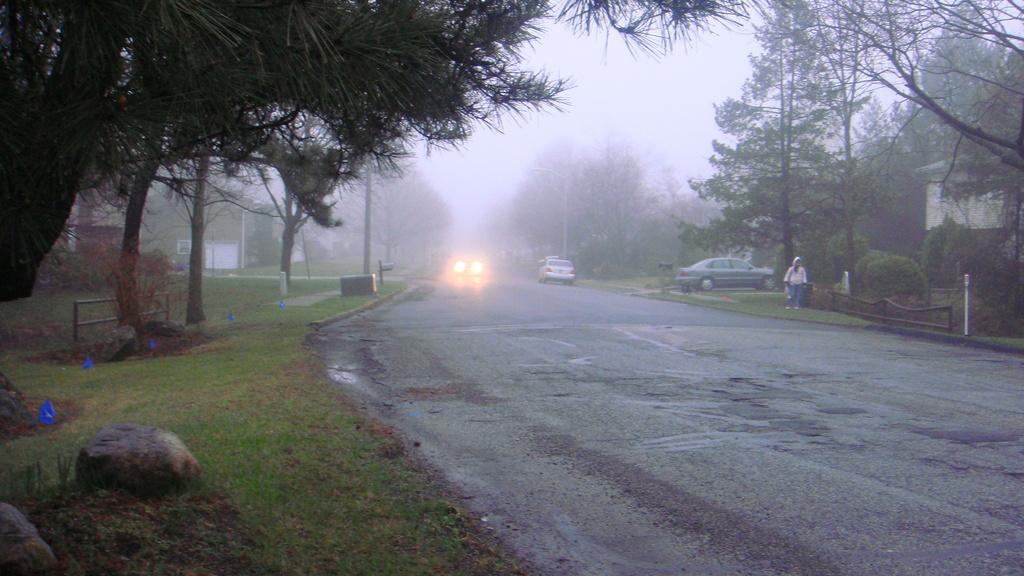What types of structures can be seen in the image? There are houses and poles in the image. What type of pathway is present in the image? There is a road in the image. What type of natural elements are present in the image? There are trees, plants, grass, and stones in the image. What is the person in the image doing? The person is standing in the image. What can be seen in the background of the image? The sky is visible in the background of the image. How many brothers are present in the image? There are no brothers mentioned or depicted in the image. What type of cemetery can be seen in the image? There is no cemetery present in the image. 